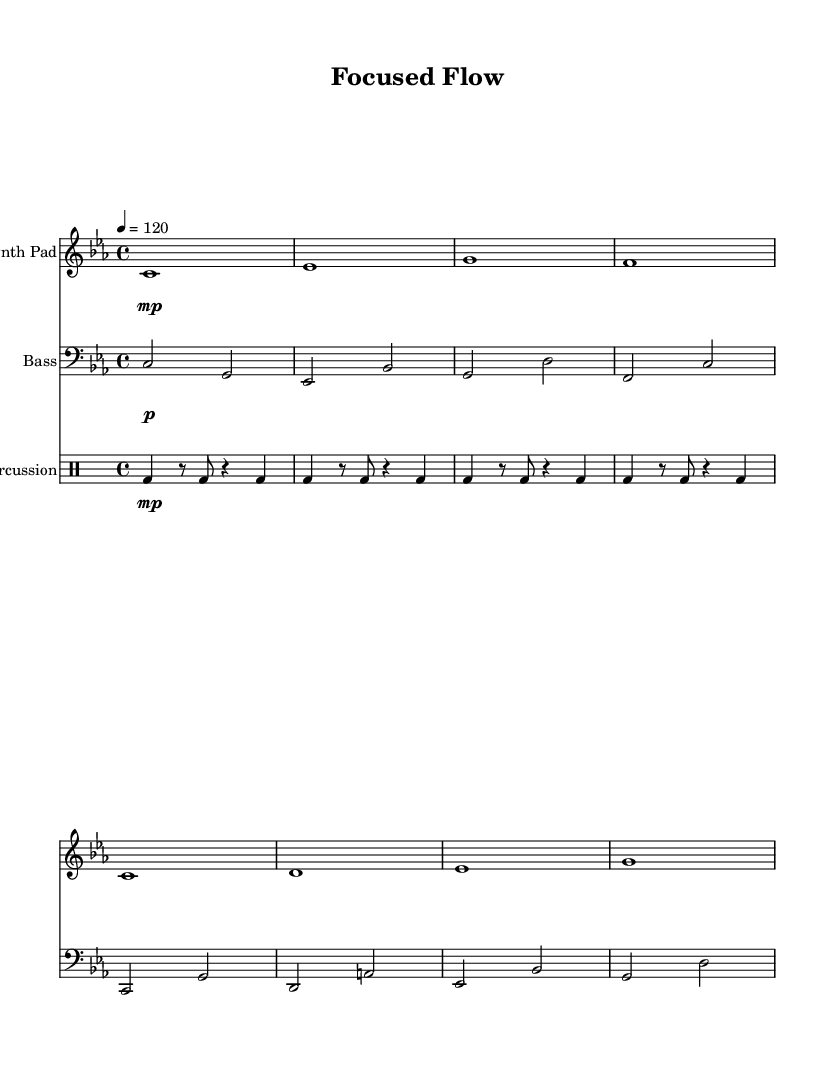What is the key signature of this music? The key signature is C minor, which has three flats (B flat, E flat, and A flat). This can be identified from the key signature indicated at the beginning of the staff lines.
Answer: C minor What is the time signature of this music? The time signature is 4/4, which indicates that there are four beats per measure and a quarter note receives one beat. This is evident from the notation appearing near the start of the music.
Answer: 4/4 What is the tempo marking of this piece? The tempo marking is 120 beats per minute, indicated at the beginning of the score. It is shown as "4 = 120", meaning each quarter note is played at a speed of 120 beats per minute.
Answer: 120 What instruments are used in this music? The instruments used are a Synth Pad, Bass, and Percussion, which are explicitly written in the instrument names at the beginning of each staff.
Answer: Synth Pad, Bass, Percussion How many measures are in the Synth Pad part? There are 8 measures in the Synth Pad part, as counted by the number of vertical bar lines separating the musical phrases. Each phrase is represented within a measure up to the end of the staff.
Answer: 8 What dynamic marking is used for the Bass? The dynamic marking for the Bass is piano, indicated by the symbol "p" which denotes a soft volume level. This can be found in the dynamics section associated with the Bass staff.
Answer: piano 